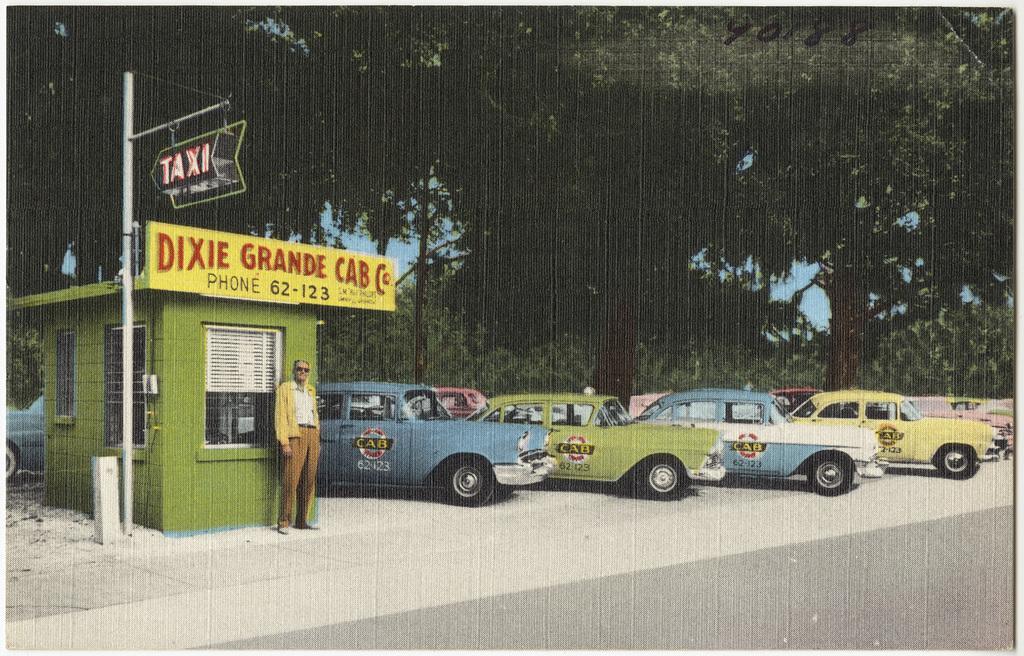How would you summarize this image in a sentence or two? In this image we can see a group of cars. A person is standing beside a building. On the building we can see the windows and the text. Beside the building we can see a pole with a board with the text. In the background, we can see a group of trees and the sky. 